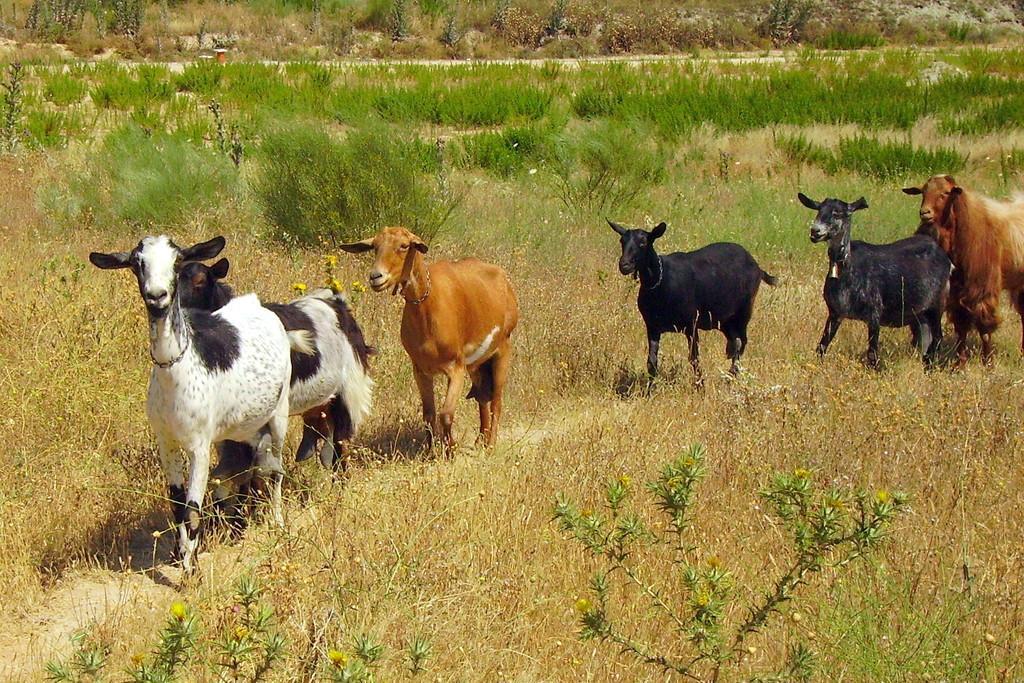Could you give a brief overview of what you see in this image? In this picture , we can see many goat walking and on the ground there are many grasses. 